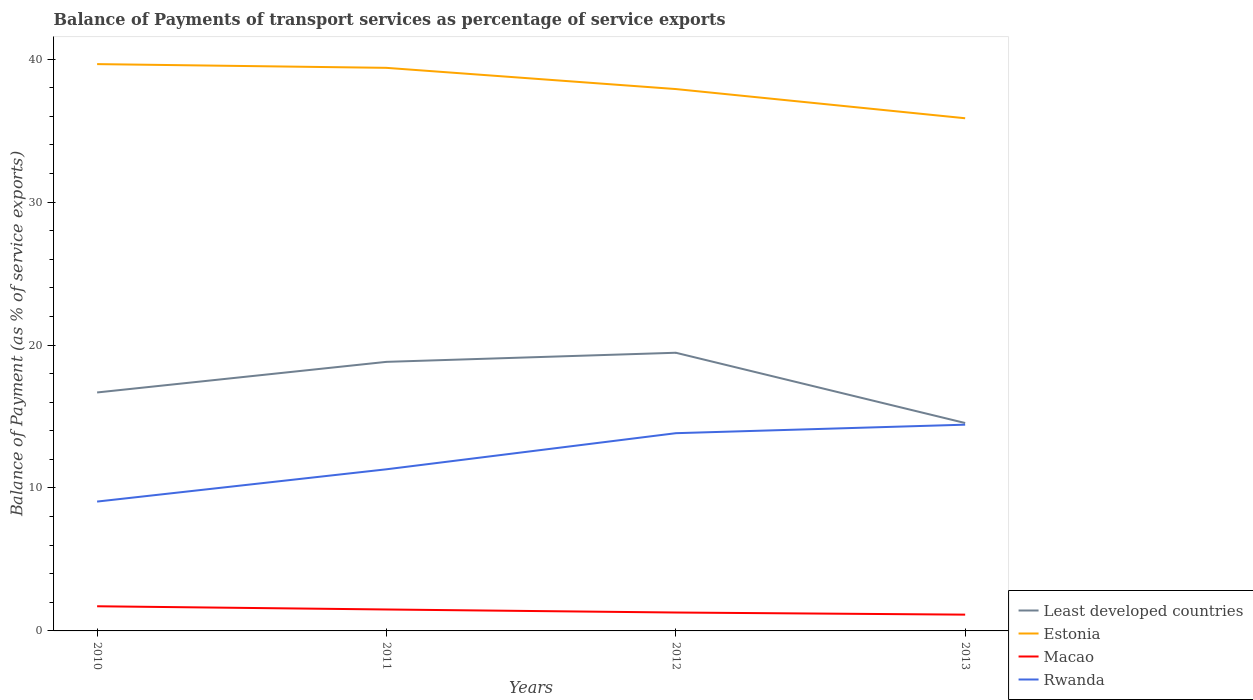How many different coloured lines are there?
Offer a very short reply. 4. Does the line corresponding to Least developed countries intersect with the line corresponding to Estonia?
Offer a terse response. No. Across all years, what is the maximum balance of payments of transport services in Rwanda?
Your answer should be compact. 9.05. What is the total balance of payments of transport services in Least developed countries in the graph?
Give a very brief answer. -2.14. What is the difference between the highest and the second highest balance of payments of transport services in Estonia?
Provide a short and direct response. 3.79. Does the graph contain any zero values?
Offer a terse response. No. Does the graph contain grids?
Your answer should be compact. No. How many legend labels are there?
Ensure brevity in your answer.  4. How are the legend labels stacked?
Keep it short and to the point. Vertical. What is the title of the graph?
Keep it short and to the point. Balance of Payments of transport services as percentage of service exports. What is the label or title of the Y-axis?
Provide a short and direct response. Balance of Payment (as % of service exports). What is the Balance of Payment (as % of service exports) in Least developed countries in 2010?
Your answer should be compact. 16.68. What is the Balance of Payment (as % of service exports) of Estonia in 2010?
Offer a very short reply. 39.65. What is the Balance of Payment (as % of service exports) of Macao in 2010?
Provide a succinct answer. 1.72. What is the Balance of Payment (as % of service exports) in Rwanda in 2010?
Your answer should be very brief. 9.05. What is the Balance of Payment (as % of service exports) in Least developed countries in 2011?
Ensure brevity in your answer.  18.82. What is the Balance of Payment (as % of service exports) of Estonia in 2011?
Your answer should be compact. 39.39. What is the Balance of Payment (as % of service exports) of Macao in 2011?
Make the answer very short. 1.5. What is the Balance of Payment (as % of service exports) in Rwanda in 2011?
Your answer should be very brief. 11.31. What is the Balance of Payment (as % of service exports) of Least developed countries in 2012?
Offer a terse response. 19.46. What is the Balance of Payment (as % of service exports) in Estonia in 2012?
Offer a terse response. 37.91. What is the Balance of Payment (as % of service exports) of Macao in 2012?
Ensure brevity in your answer.  1.29. What is the Balance of Payment (as % of service exports) of Rwanda in 2012?
Your answer should be compact. 13.83. What is the Balance of Payment (as % of service exports) in Least developed countries in 2013?
Offer a terse response. 14.54. What is the Balance of Payment (as % of service exports) in Estonia in 2013?
Your answer should be very brief. 35.87. What is the Balance of Payment (as % of service exports) of Macao in 2013?
Ensure brevity in your answer.  1.14. What is the Balance of Payment (as % of service exports) in Rwanda in 2013?
Give a very brief answer. 14.43. Across all years, what is the maximum Balance of Payment (as % of service exports) in Least developed countries?
Offer a terse response. 19.46. Across all years, what is the maximum Balance of Payment (as % of service exports) in Estonia?
Your answer should be compact. 39.65. Across all years, what is the maximum Balance of Payment (as % of service exports) in Macao?
Offer a very short reply. 1.72. Across all years, what is the maximum Balance of Payment (as % of service exports) in Rwanda?
Your answer should be compact. 14.43. Across all years, what is the minimum Balance of Payment (as % of service exports) of Least developed countries?
Provide a succinct answer. 14.54. Across all years, what is the minimum Balance of Payment (as % of service exports) of Estonia?
Ensure brevity in your answer.  35.87. Across all years, what is the minimum Balance of Payment (as % of service exports) in Macao?
Ensure brevity in your answer.  1.14. Across all years, what is the minimum Balance of Payment (as % of service exports) of Rwanda?
Your answer should be very brief. 9.05. What is the total Balance of Payment (as % of service exports) in Least developed countries in the graph?
Give a very brief answer. 69.51. What is the total Balance of Payment (as % of service exports) in Estonia in the graph?
Offer a terse response. 152.82. What is the total Balance of Payment (as % of service exports) of Macao in the graph?
Keep it short and to the point. 5.65. What is the total Balance of Payment (as % of service exports) in Rwanda in the graph?
Ensure brevity in your answer.  48.62. What is the difference between the Balance of Payment (as % of service exports) in Least developed countries in 2010 and that in 2011?
Give a very brief answer. -2.14. What is the difference between the Balance of Payment (as % of service exports) of Estonia in 2010 and that in 2011?
Your response must be concise. 0.26. What is the difference between the Balance of Payment (as % of service exports) in Macao in 2010 and that in 2011?
Make the answer very short. 0.23. What is the difference between the Balance of Payment (as % of service exports) in Rwanda in 2010 and that in 2011?
Make the answer very short. -2.26. What is the difference between the Balance of Payment (as % of service exports) of Least developed countries in 2010 and that in 2012?
Keep it short and to the point. -2.78. What is the difference between the Balance of Payment (as % of service exports) in Estonia in 2010 and that in 2012?
Keep it short and to the point. 1.75. What is the difference between the Balance of Payment (as % of service exports) of Macao in 2010 and that in 2012?
Provide a succinct answer. 0.44. What is the difference between the Balance of Payment (as % of service exports) in Rwanda in 2010 and that in 2012?
Offer a terse response. -4.78. What is the difference between the Balance of Payment (as % of service exports) of Least developed countries in 2010 and that in 2013?
Give a very brief answer. 2.14. What is the difference between the Balance of Payment (as % of service exports) of Estonia in 2010 and that in 2013?
Offer a very short reply. 3.79. What is the difference between the Balance of Payment (as % of service exports) in Macao in 2010 and that in 2013?
Your response must be concise. 0.59. What is the difference between the Balance of Payment (as % of service exports) in Rwanda in 2010 and that in 2013?
Offer a terse response. -5.38. What is the difference between the Balance of Payment (as % of service exports) in Least developed countries in 2011 and that in 2012?
Make the answer very short. -0.64. What is the difference between the Balance of Payment (as % of service exports) of Estonia in 2011 and that in 2012?
Make the answer very short. 1.48. What is the difference between the Balance of Payment (as % of service exports) in Macao in 2011 and that in 2012?
Keep it short and to the point. 0.21. What is the difference between the Balance of Payment (as % of service exports) in Rwanda in 2011 and that in 2012?
Provide a short and direct response. -2.53. What is the difference between the Balance of Payment (as % of service exports) of Least developed countries in 2011 and that in 2013?
Your response must be concise. 4.28. What is the difference between the Balance of Payment (as % of service exports) of Estonia in 2011 and that in 2013?
Provide a short and direct response. 3.53. What is the difference between the Balance of Payment (as % of service exports) of Macao in 2011 and that in 2013?
Your answer should be very brief. 0.36. What is the difference between the Balance of Payment (as % of service exports) in Rwanda in 2011 and that in 2013?
Provide a short and direct response. -3.12. What is the difference between the Balance of Payment (as % of service exports) in Least developed countries in 2012 and that in 2013?
Give a very brief answer. 4.92. What is the difference between the Balance of Payment (as % of service exports) of Estonia in 2012 and that in 2013?
Ensure brevity in your answer.  2.04. What is the difference between the Balance of Payment (as % of service exports) of Macao in 2012 and that in 2013?
Your response must be concise. 0.15. What is the difference between the Balance of Payment (as % of service exports) of Rwanda in 2012 and that in 2013?
Provide a short and direct response. -0.6. What is the difference between the Balance of Payment (as % of service exports) in Least developed countries in 2010 and the Balance of Payment (as % of service exports) in Estonia in 2011?
Give a very brief answer. -22.71. What is the difference between the Balance of Payment (as % of service exports) of Least developed countries in 2010 and the Balance of Payment (as % of service exports) of Macao in 2011?
Make the answer very short. 15.18. What is the difference between the Balance of Payment (as % of service exports) in Least developed countries in 2010 and the Balance of Payment (as % of service exports) in Rwanda in 2011?
Keep it short and to the point. 5.38. What is the difference between the Balance of Payment (as % of service exports) in Estonia in 2010 and the Balance of Payment (as % of service exports) in Macao in 2011?
Your response must be concise. 38.15. What is the difference between the Balance of Payment (as % of service exports) of Estonia in 2010 and the Balance of Payment (as % of service exports) of Rwanda in 2011?
Keep it short and to the point. 28.35. What is the difference between the Balance of Payment (as % of service exports) of Macao in 2010 and the Balance of Payment (as % of service exports) of Rwanda in 2011?
Your answer should be compact. -9.58. What is the difference between the Balance of Payment (as % of service exports) in Least developed countries in 2010 and the Balance of Payment (as % of service exports) in Estonia in 2012?
Give a very brief answer. -21.23. What is the difference between the Balance of Payment (as % of service exports) of Least developed countries in 2010 and the Balance of Payment (as % of service exports) of Macao in 2012?
Keep it short and to the point. 15.4. What is the difference between the Balance of Payment (as % of service exports) in Least developed countries in 2010 and the Balance of Payment (as % of service exports) in Rwanda in 2012?
Provide a succinct answer. 2.85. What is the difference between the Balance of Payment (as % of service exports) of Estonia in 2010 and the Balance of Payment (as % of service exports) of Macao in 2012?
Your answer should be compact. 38.37. What is the difference between the Balance of Payment (as % of service exports) of Estonia in 2010 and the Balance of Payment (as % of service exports) of Rwanda in 2012?
Offer a terse response. 25.82. What is the difference between the Balance of Payment (as % of service exports) in Macao in 2010 and the Balance of Payment (as % of service exports) in Rwanda in 2012?
Keep it short and to the point. -12.11. What is the difference between the Balance of Payment (as % of service exports) in Least developed countries in 2010 and the Balance of Payment (as % of service exports) in Estonia in 2013?
Provide a succinct answer. -19.18. What is the difference between the Balance of Payment (as % of service exports) of Least developed countries in 2010 and the Balance of Payment (as % of service exports) of Macao in 2013?
Keep it short and to the point. 15.54. What is the difference between the Balance of Payment (as % of service exports) of Least developed countries in 2010 and the Balance of Payment (as % of service exports) of Rwanda in 2013?
Ensure brevity in your answer.  2.25. What is the difference between the Balance of Payment (as % of service exports) in Estonia in 2010 and the Balance of Payment (as % of service exports) in Macao in 2013?
Provide a succinct answer. 38.52. What is the difference between the Balance of Payment (as % of service exports) of Estonia in 2010 and the Balance of Payment (as % of service exports) of Rwanda in 2013?
Your response must be concise. 25.23. What is the difference between the Balance of Payment (as % of service exports) in Macao in 2010 and the Balance of Payment (as % of service exports) in Rwanda in 2013?
Make the answer very short. -12.7. What is the difference between the Balance of Payment (as % of service exports) in Least developed countries in 2011 and the Balance of Payment (as % of service exports) in Estonia in 2012?
Provide a short and direct response. -19.08. What is the difference between the Balance of Payment (as % of service exports) in Least developed countries in 2011 and the Balance of Payment (as % of service exports) in Macao in 2012?
Offer a terse response. 17.54. What is the difference between the Balance of Payment (as % of service exports) of Least developed countries in 2011 and the Balance of Payment (as % of service exports) of Rwanda in 2012?
Offer a very short reply. 4.99. What is the difference between the Balance of Payment (as % of service exports) of Estonia in 2011 and the Balance of Payment (as % of service exports) of Macao in 2012?
Give a very brief answer. 38.1. What is the difference between the Balance of Payment (as % of service exports) in Estonia in 2011 and the Balance of Payment (as % of service exports) in Rwanda in 2012?
Your response must be concise. 25.56. What is the difference between the Balance of Payment (as % of service exports) of Macao in 2011 and the Balance of Payment (as % of service exports) of Rwanda in 2012?
Provide a short and direct response. -12.33. What is the difference between the Balance of Payment (as % of service exports) in Least developed countries in 2011 and the Balance of Payment (as % of service exports) in Estonia in 2013?
Make the answer very short. -17.04. What is the difference between the Balance of Payment (as % of service exports) of Least developed countries in 2011 and the Balance of Payment (as % of service exports) of Macao in 2013?
Provide a succinct answer. 17.69. What is the difference between the Balance of Payment (as % of service exports) of Least developed countries in 2011 and the Balance of Payment (as % of service exports) of Rwanda in 2013?
Provide a succinct answer. 4.39. What is the difference between the Balance of Payment (as % of service exports) in Estonia in 2011 and the Balance of Payment (as % of service exports) in Macao in 2013?
Provide a short and direct response. 38.25. What is the difference between the Balance of Payment (as % of service exports) in Estonia in 2011 and the Balance of Payment (as % of service exports) in Rwanda in 2013?
Give a very brief answer. 24.96. What is the difference between the Balance of Payment (as % of service exports) in Macao in 2011 and the Balance of Payment (as % of service exports) in Rwanda in 2013?
Your answer should be compact. -12.93. What is the difference between the Balance of Payment (as % of service exports) in Least developed countries in 2012 and the Balance of Payment (as % of service exports) in Estonia in 2013?
Keep it short and to the point. -16.41. What is the difference between the Balance of Payment (as % of service exports) of Least developed countries in 2012 and the Balance of Payment (as % of service exports) of Macao in 2013?
Your answer should be very brief. 18.32. What is the difference between the Balance of Payment (as % of service exports) in Least developed countries in 2012 and the Balance of Payment (as % of service exports) in Rwanda in 2013?
Your response must be concise. 5.03. What is the difference between the Balance of Payment (as % of service exports) of Estonia in 2012 and the Balance of Payment (as % of service exports) of Macao in 2013?
Your answer should be very brief. 36.77. What is the difference between the Balance of Payment (as % of service exports) of Estonia in 2012 and the Balance of Payment (as % of service exports) of Rwanda in 2013?
Provide a short and direct response. 23.48. What is the difference between the Balance of Payment (as % of service exports) of Macao in 2012 and the Balance of Payment (as % of service exports) of Rwanda in 2013?
Your response must be concise. -13.14. What is the average Balance of Payment (as % of service exports) of Least developed countries per year?
Your answer should be very brief. 17.38. What is the average Balance of Payment (as % of service exports) in Estonia per year?
Keep it short and to the point. 38.21. What is the average Balance of Payment (as % of service exports) of Macao per year?
Offer a very short reply. 1.41. What is the average Balance of Payment (as % of service exports) in Rwanda per year?
Provide a short and direct response. 12.15. In the year 2010, what is the difference between the Balance of Payment (as % of service exports) of Least developed countries and Balance of Payment (as % of service exports) of Estonia?
Keep it short and to the point. -22.97. In the year 2010, what is the difference between the Balance of Payment (as % of service exports) of Least developed countries and Balance of Payment (as % of service exports) of Macao?
Keep it short and to the point. 14.96. In the year 2010, what is the difference between the Balance of Payment (as % of service exports) of Least developed countries and Balance of Payment (as % of service exports) of Rwanda?
Make the answer very short. 7.63. In the year 2010, what is the difference between the Balance of Payment (as % of service exports) of Estonia and Balance of Payment (as % of service exports) of Macao?
Ensure brevity in your answer.  37.93. In the year 2010, what is the difference between the Balance of Payment (as % of service exports) in Estonia and Balance of Payment (as % of service exports) in Rwanda?
Offer a terse response. 30.61. In the year 2010, what is the difference between the Balance of Payment (as % of service exports) of Macao and Balance of Payment (as % of service exports) of Rwanda?
Keep it short and to the point. -7.32. In the year 2011, what is the difference between the Balance of Payment (as % of service exports) of Least developed countries and Balance of Payment (as % of service exports) of Estonia?
Provide a short and direct response. -20.57. In the year 2011, what is the difference between the Balance of Payment (as % of service exports) in Least developed countries and Balance of Payment (as % of service exports) in Macao?
Provide a short and direct response. 17.32. In the year 2011, what is the difference between the Balance of Payment (as % of service exports) in Least developed countries and Balance of Payment (as % of service exports) in Rwanda?
Keep it short and to the point. 7.52. In the year 2011, what is the difference between the Balance of Payment (as % of service exports) of Estonia and Balance of Payment (as % of service exports) of Macao?
Make the answer very short. 37.89. In the year 2011, what is the difference between the Balance of Payment (as % of service exports) of Estonia and Balance of Payment (as % of service exports) of Rwanda?
Make the answer very short. 28.08. In the year 2011, what is the difference between the Balance of Payment (as % of service exports) in Macao and Balance of Payment (as % of service exports) in Rwanda?
Ensure brevity in your answer.  -9.81. In the year 2012, what is the difference between the Balance of Payment (as % of service exports) in Least developed countries and Balance of Payment (as % of service exports) in Estonia?
Your answer should be very brief. -18.45. In the year 2012, what is the difference between the Balance of Payment (as % of service exports) in Least developed countries and Balance of Payment (as % of service exports) in Macao?
Your response must be concise. 18.17. In the year 2012, what is the difference between the Balance of Payment (as % of service exports) of Least developed countries and Balance of Payment (as % of service exports) of Rwanda?
Offer a very short reply. 5.63. In the year 2012, what is the difference between the Balance of Payment (as % of service exports) in Estonia and Balance of Payment (as % of service exports) in Macao?
Offer a very short reply. 36.62. In the year 2012, what is the difference between the Balance of Payment (as % of service exports) of Estonia and Balance of Payment (as % of service exports) of Rwanda?
Offer a very short reply. 24.08. In the year 2012, what is the difference between the Balance of Payment (as % of service exports) of Macao and Balance of Payment (as % of service exports) of Rwanda?
Your answer should be compact. -12.55. In the year 2013, what is the difference between the Balance of Payment (as % of service exports) in Least developed countries and Balance of Payment (as % of service exports) in Estonia?
Your answer should be compact. -21.32. In the year 2013, what is the difference between the Balance of Payment (as % of service exports) in Least developed countries and Balance of Payment (as % of service exports) in Macao?
Provide a short and direct response. 13.41. In the year 2013, what is the difference between the Balance of Payment (as % of service exports) of Least developed countries and Balance of Payment (as % of service exports) of Rwanda?
Keep it short and to the point. 0.12. In the year 2013, what is the difference between the Balance of Payment (as % of service exports) of Estonia and Balance of Payment (as % of service exports) of Macao?
Provide a short and direct response. 34.73. In the year 2013, what is the difference between the Balance of Payment (as % of service exports) in Estonia and Balance of Payment (as % of service exports) in Rwanda?
Offer a very short reply. 21.44. In the year 2013, what is the difference between the Balance of Payment (as % of service exports) of Macao and Balance of Payment (as % of service exports) of Rwanda?
Make the answer very short. -13.29. What is the ratio of the Balance of Payment (as % of service exports) of Least developed countries in 2010 to that in 2011?
Your answer should be very brief. 0.89. What is the ratio of the Balance of Payment (as % of service exports) in Macao in 2010 to that in 2011?
Provide a short and direct response. 1.15. What is the ratio of the Balance of Payment (as % of service exports) in Rwanda in 2010 to that in 2011?
Offer a terse response. 0.8. What is the ratio of the Balance of Payment (as % of service exports) of Least developed countries in 2010 to that in 2012?
Keep it short and to the point. 0.86. What is the ratio of the Balance of Payment (as % of service exports) in Estonia in 2010 to that in 2012?
Ensure brevity in your answer.  1.05. What is the ratio of the Balance of Payment (as % of service exports) of Macao in 2010 to that in 2012?
Your answer should be very brief. 1.34. What is the ratio of the Balance of Payment (as % of service exports) in Rwanda in 2010 to that in 2012?
Your answer should be very brief. 0.65. What is the ratio of the Balance of Payment (as % of service exports) of Least developed countries in 2010 to that in 2013?
Provide a short and direct response. 1.15. What is the ratio of the Balance of Payment (as % of service exports) of Estonia in 2010 to that in 2013?
Give a very brief answer. 1.11. What is the ratio of the Balance of Payment (as % of service exports) in Macao in 2010 to that in 2013?
Ensure brevity in your answer.  1.51. What is the ratio of the Balance of Payment (as % of service exports) in Rwanda in 2010 to that in 2013?
Offer a terse response. 0.63. What is the ratio of the Balance of Payment (as % of service exports) in Least developed countries in 2011 to that in 2012?
Make the answer very short. 0.97. What is the ratio of the Balance of Payment (as % of service exports) of Estonia in 2011 to that in 2012?
Give a very brief answer. 1.04. What is the ratio of the Balance of Payment (as % of service exports) of Macao in 2011 to that in 2012?
Offer a very short reply. 1.16. What is the ratio of the Balance of Payment (as % of service exports) of Rwanda in 2011 to that in 2012?
Offer a terse response. 0.82. What is the ratio of the Balance of Payment (as % of service exports) of Least developed countries in 2011 to that in 2013?
Offer a very short reply. 1.29. What is the ratio of the Balance of Payment (as % of service exports) of Estonia in 2011 to that in 2013?
Your answer should be compact. 1.1. What is the ratio of the Balance of Payment (as % of service exports) in Macao in 2011 to that in 2013?
Your response must be concise. 1.32. What is the ratio of the Balance of Payment (as % of service exports) in Rwanda in 2011 to that in 2013?
Make the answer very short. 0.78. What is the ratio of the Balance of Payment (as % of service exports) of Least developed countries in 2012 to that in 2013?
Provide a short and direct response. 1.34. What is the ratio of the Balance of Payment (as % of service exports) of Estonia in 2012 to that in 2013?
Make the answer very short. 1.06. What is the ratio of the Balance of Payment (as % of service exports) of Macao in 2012 to that in 2013?
Keep it short and to the point. 1.13. What is the ratio of the Balance of Payment (as % of service exports) of Rwanda in 2012 to that in 2013?
Give a very brief answer. 0.96. What is the difference between the highest and the second highest Balance of Payment (as % of service exports) in Least developed countries?
Offer a very short reply. 0.64. What is the difference between the highest and the second highest Balance of Payment (as % of service exports) in Estonia?
Ensure brevity in your answer.  0.26. What is the difference between the highest and the second highest Balance of Payment (as % of service exports) in Macao?
Keep it short and to the point. 0.23. What is the difference between the highest and the second highest Balance of Payment (as % of service exports) in Rwanda?
Make the answer very short. 0.6. What is the difference between the highest and the lowest Balance of Payment (as % of service exports) of Least developed countries?
Provide a short and direct response. 4.92. What is the difference between the highest and the lowest Balance of Payment (as % of service exports) of Estonia?
Provide a short and direct response. 3.79. What is the difference between the highest and the lowest Balance of Payment (as % of service exports) in Macao?
Make the answer very short. 0.59. What is the difference between the highest and the lowest Balance of Payment (as % of service exports) of Rwanda?
Your response must be concise. 5.38. 